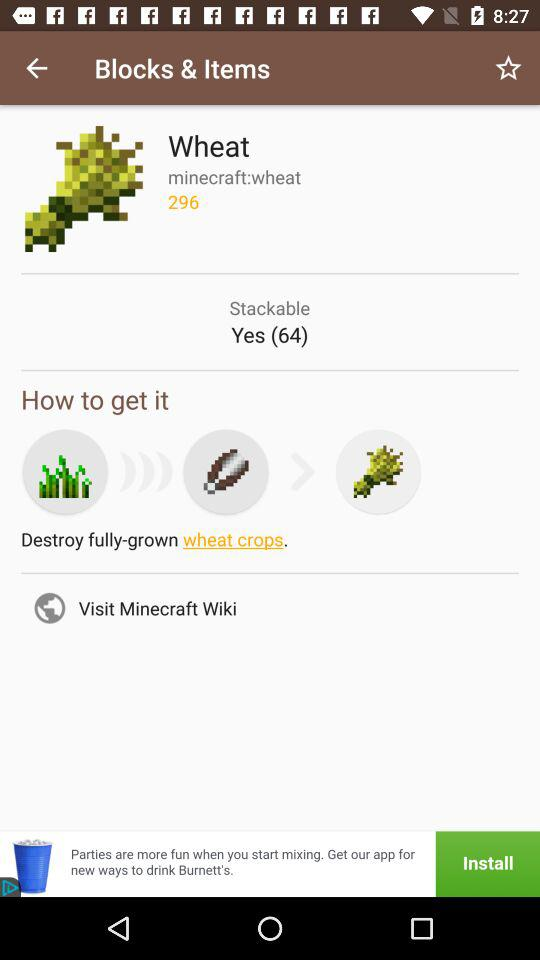How many stackable items are there? There are 64 stackable items. 